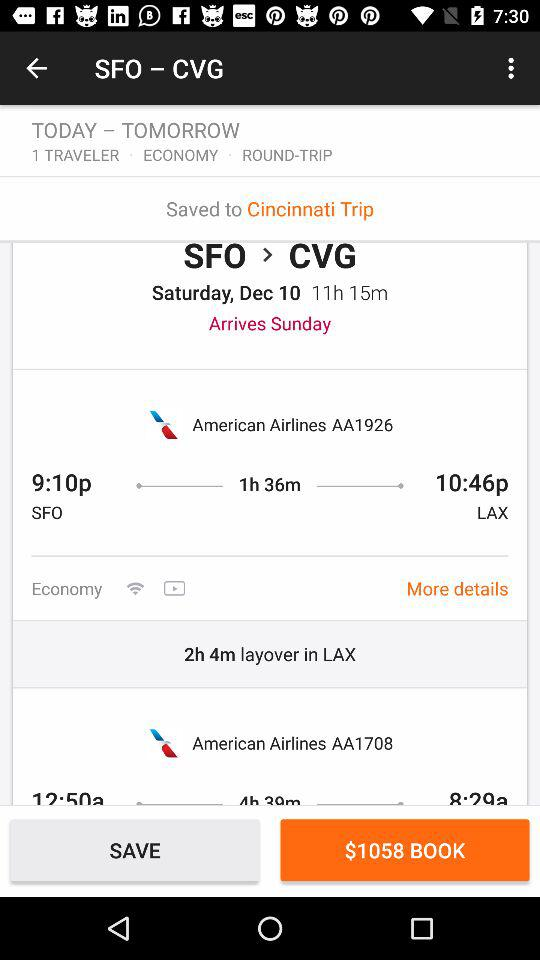What is the departure time of the flight from San Francisco? The departure time is 9:10 PM. 